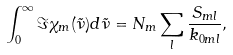<formula> <loc_0><loc_0><loc_500><loc_500>\int _ { 0 } ^ { \infty } \Im \chi _ { m } ( \tilde { \nu } ) d \tilde { \nu } = N _ { m } \sum _ { l } \frac { S _ { m l } } { k _ { 0 m l } } ,</formula> 